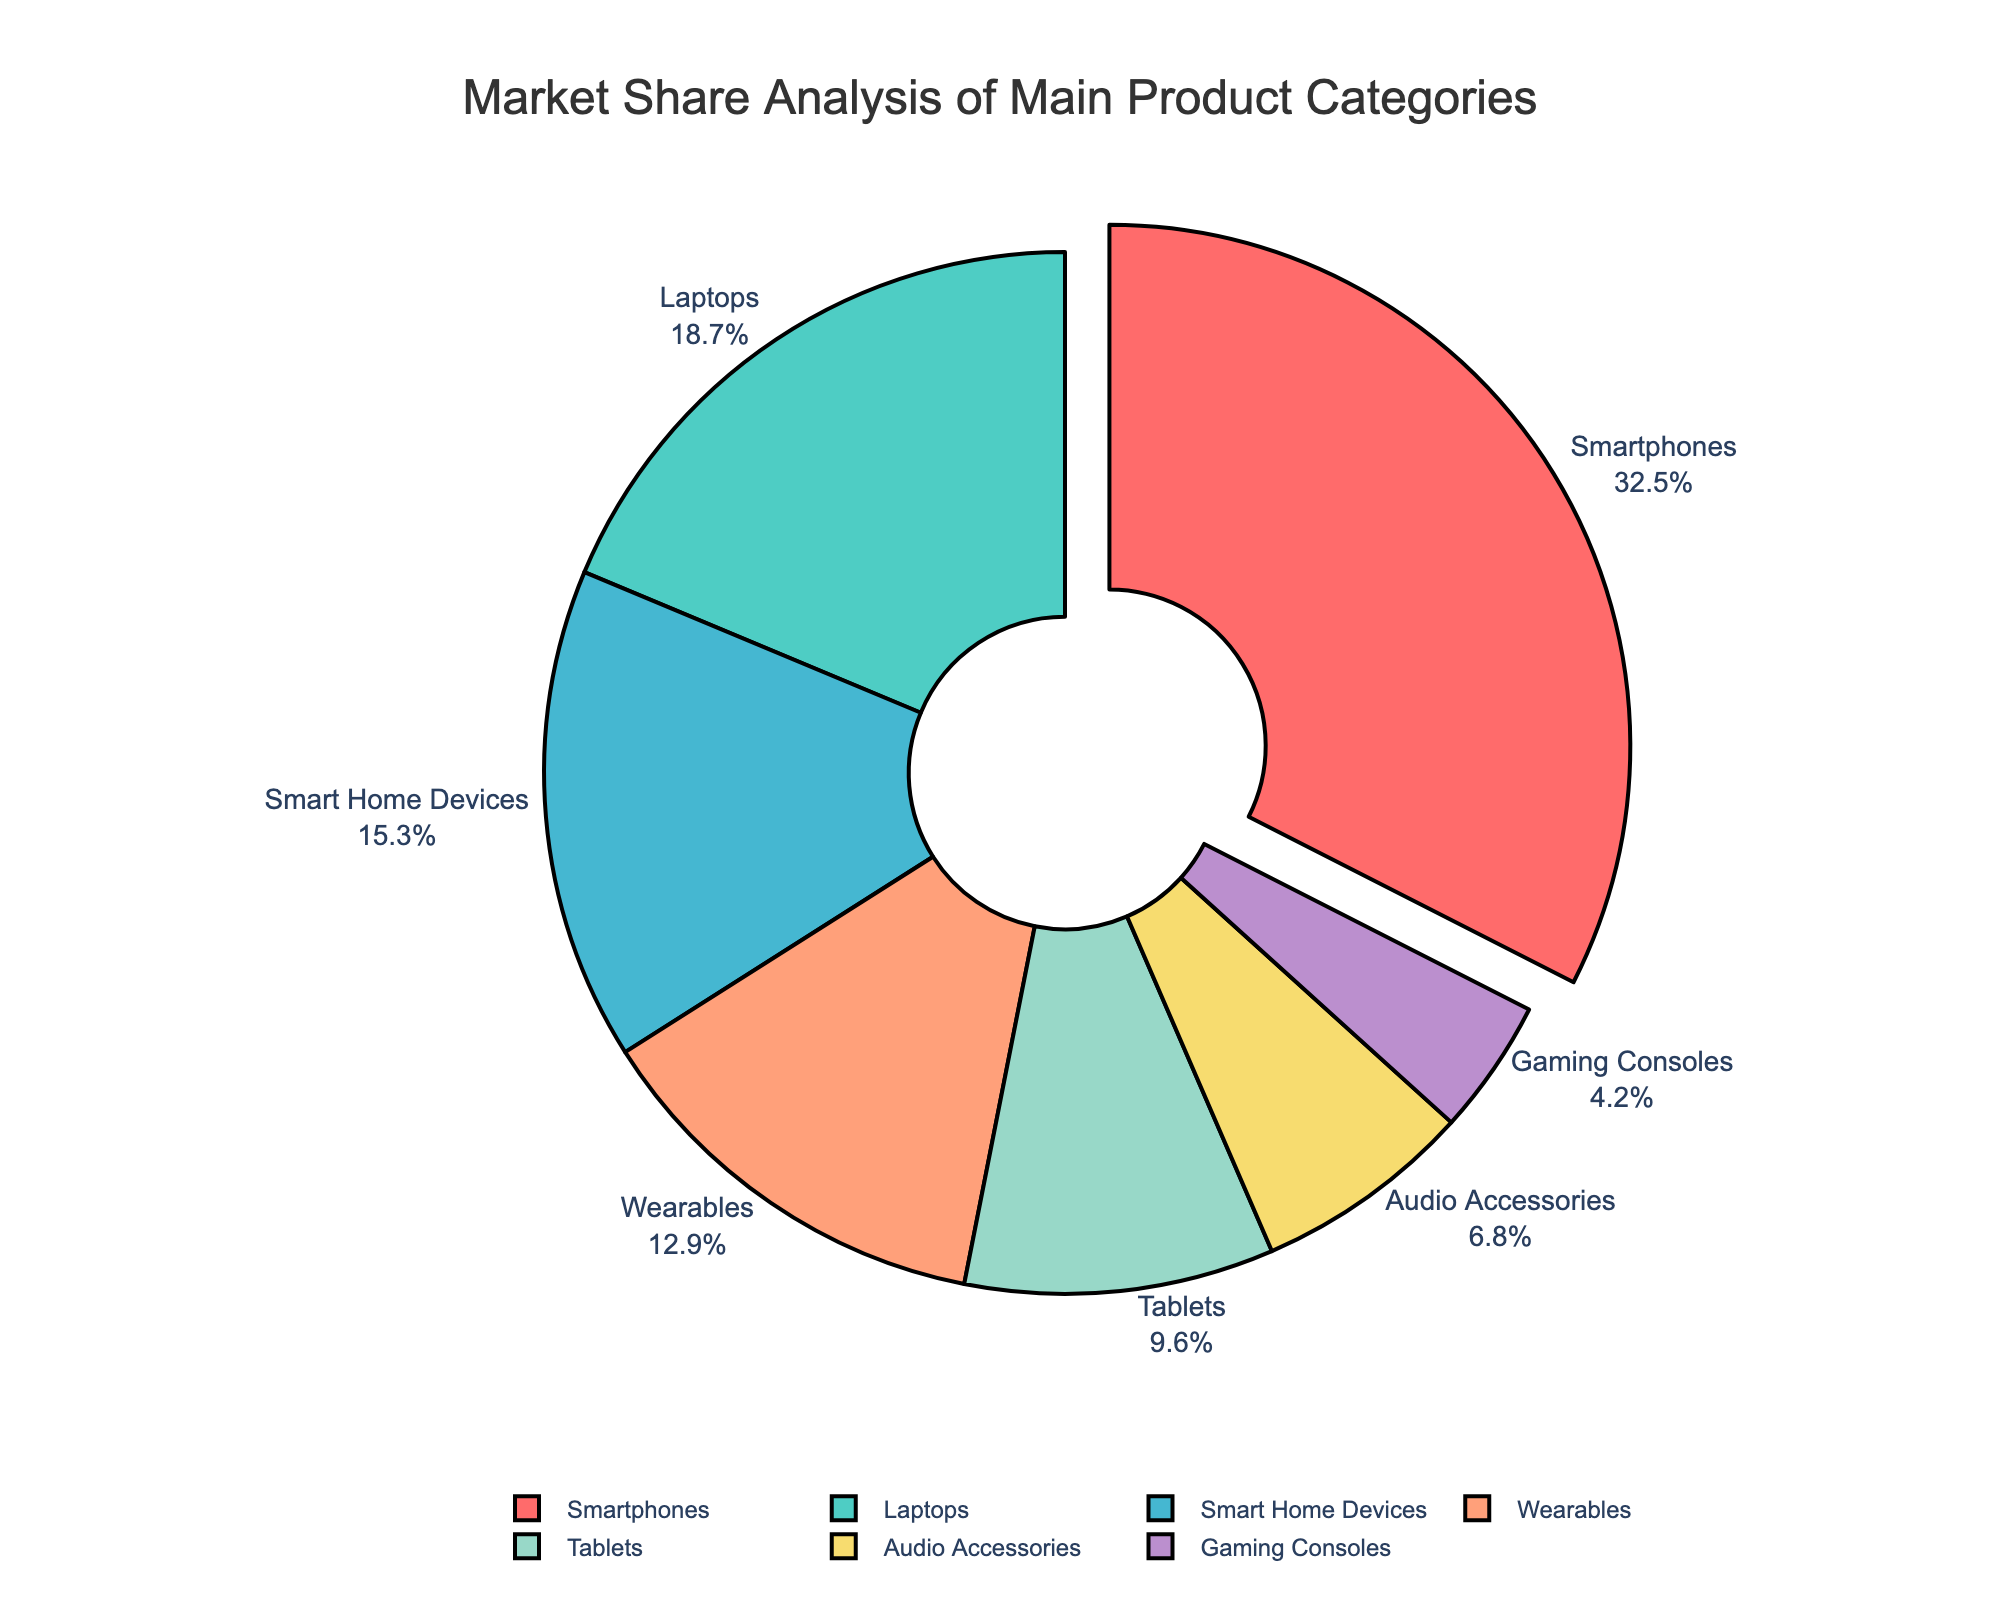What is the product category with the largest market share? The largest market share is represented by the segment that is pulled out from the others. This segment corresponds to Smartphones, which has a market share of 32.5%.
Answer: Smartphones Which two product categories combined have a market share greater than Wearables? Wearables have a market share of 12.9%. If we sum the market shares of the two smallest categories, Gaming Consoles (4.2%) and Audio Accessories (6.8%), we get 11%. The next smallest category is Tablets with a market share of 9.6%. Adding Tablets to the smallest category (Gaming Consoles) gives 9.6% + 4.2% = 13.8%, which is greater than 12.9%.
Answer: Tablets and Gaming Consoles What is the difference in market share between Smart Home Devices and Tablets? Smart Home Devices have a market share of 15.3%, while Tablets have a market share of 9.6%. The difference in their market shares is calculated as 15.3% - 9.6% = 5.7%.
Answer: 5.7% What percentage of market share do the top three categories hold together? The top three categories by market share are Smartphones (32.5%), Laptops (18.7%), and Smart Home Devices (15.3%). Summing these values, we get 32.5% + 18.7% + 15.3% = 66.5%.
Answer: 66.5% Which product category has a market share closest to 10%? By examining each segment, the category with a market share closest to 10% is Tablets with 9.6%, as 9.6% is closest to 10% compared to other categories.
Answer: Tablets What is the combined market share of Wearables and Audio Accessories? Wearables have a market share of 12.9% and Audio Accessories have 6.8%. Adding these, we get 12.9% + 6.8% = 19.7%.
Answer: 19.7% How much larger is the market share of Laptops compared to Gaming Consoles? Laptops have a market share of 18.7%, and Gaming Consoles have 4.2%. The difference is calculated as 18.7% - 4.2% = 14.5%.
Answer: 14.5% Which product category is represented by the yellow segment in the pie chart? The yellow segment corresponds to Smart Home Devices.
Answer: Smart Home Devices 